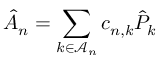<formula> <loc_0><loc_0><loc_500><loc_500>\hat { A } _ { n } = \sum _ { k \in \mathcal { A } _ { n } } c _ { n , k } \hat { P } _ { k }</formula> 